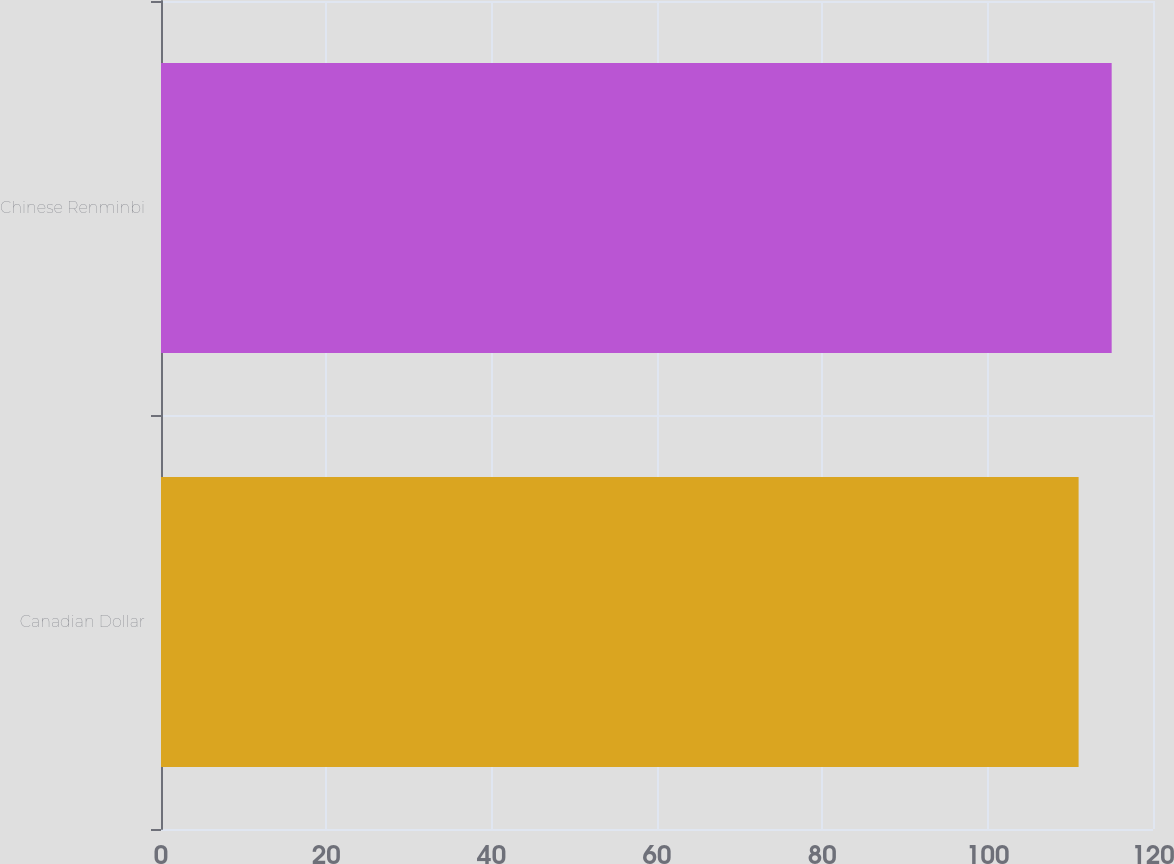Convert chart. <chart><loc_0><loc_0><loc_500><loc_500><bar_chart><fcel>Canadian Dollar<fcel>Chinese Renminbi<nl><fcel>111<fcel>115<nl></chart> 